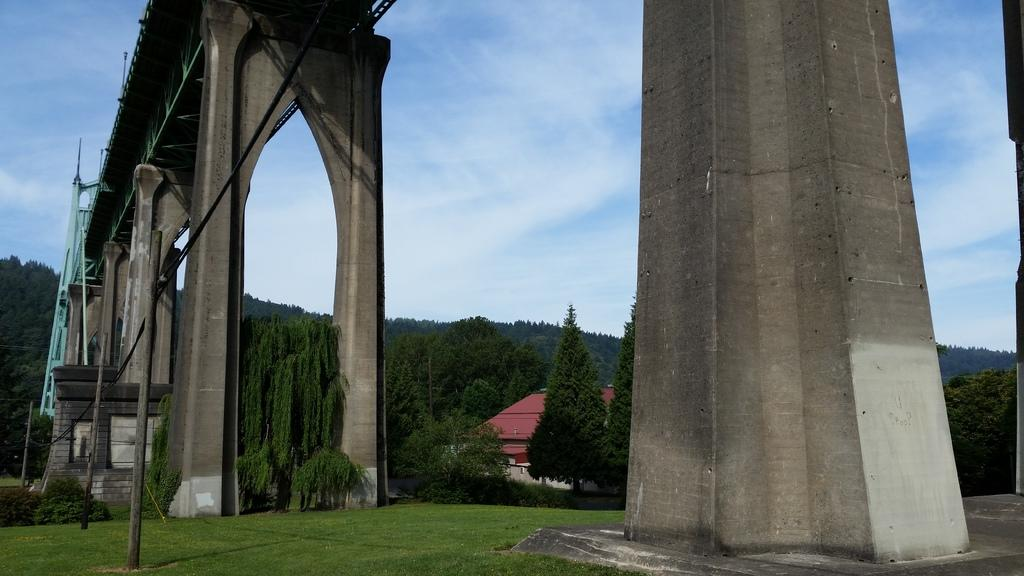What type of structure is in the image? There is a bridge in the image. What materials make up the bridge? The bridge has metal poles and pillars. What type of vegetation can be seen in the image? There is grass and a group of trees visible in the image. What other structures are present in the image? There is a house in the image. What else can be seen in the image? Wires are present in the image. What is the condition of the sky in the image? The sky is visible in the image and appears cloudy. What type of ear is visible on the bridge in the image? There is no ear present on the bridge or in the image. Can you tell me the name of the father of the person who built the bridge in the image? There is no information about the person who built the bridge or their father in the image. 